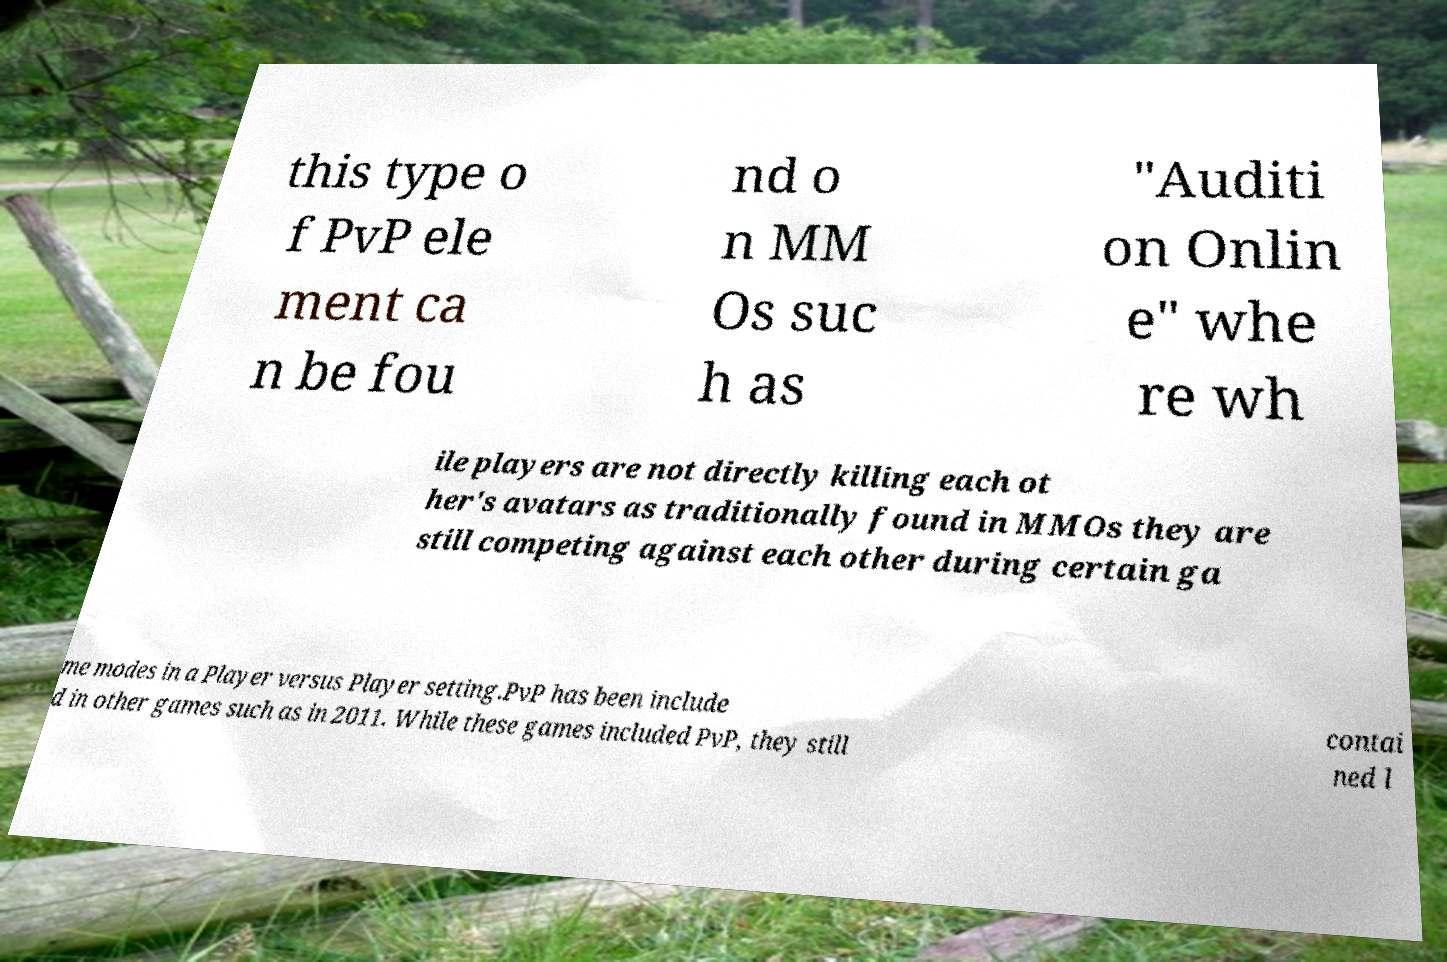What messages or text are displayed in this image? I need them in a readable, typed format. this type o f PvP ele ment ca n be fou nd o n MM Os suc h as "Auditi on Onlin e" whe re wh ile players are not directly killing each ot her's avatars as traditionally found in MMOs they are still competing against each other during certain ga me modes in a Player versus Player setting.PvP has been include d in other games such as in 2011. While these games included PvP, they still contai ned l 